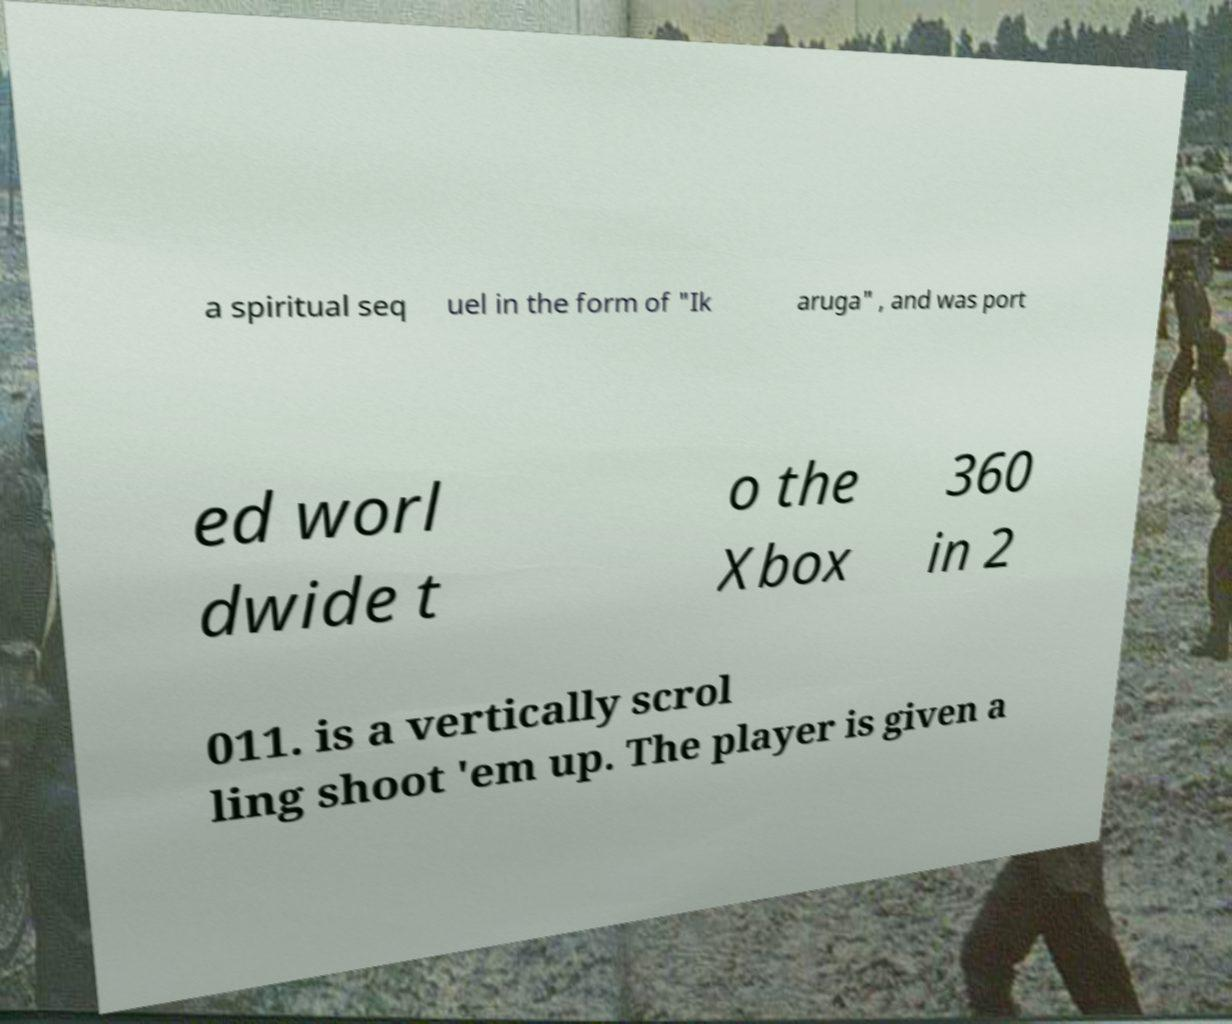Please read and relay the text visible in this image. What does it say? a spiritual seq uel in the form of "Ik aruga" , and was port ed worl dwide t o the Xbox 360 in 2 011. is a vertically scrol ling shoot 'em up. The player is given a 